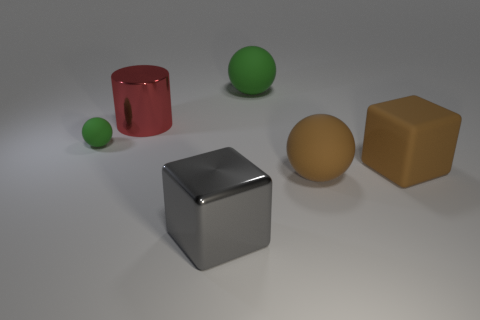What could the positioning of these objects tell us about spacing and balance in composition? The objects are arranged with attention to negative space, creating a balanced and harmonious composition. The spacing allows each object to be distinct and easily identifiable, providing a visual representation of orderly placement and proportion within the frame. 